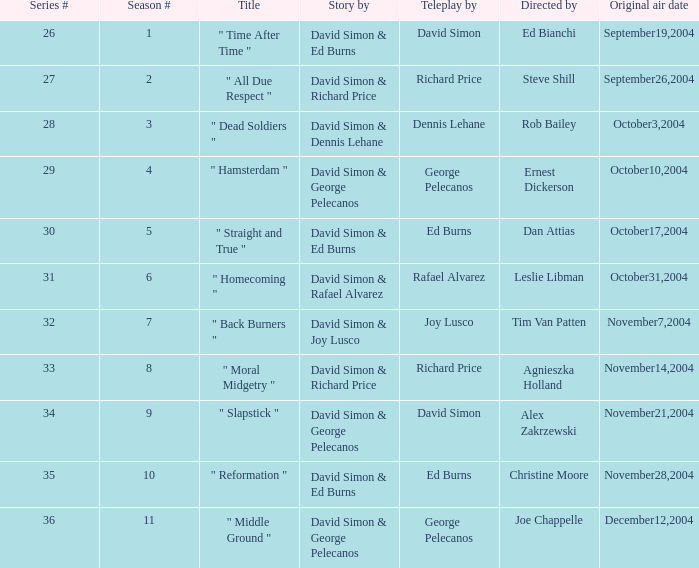What is the season number for a teleplay written by richard price and directed by steve shill? 2.0. 